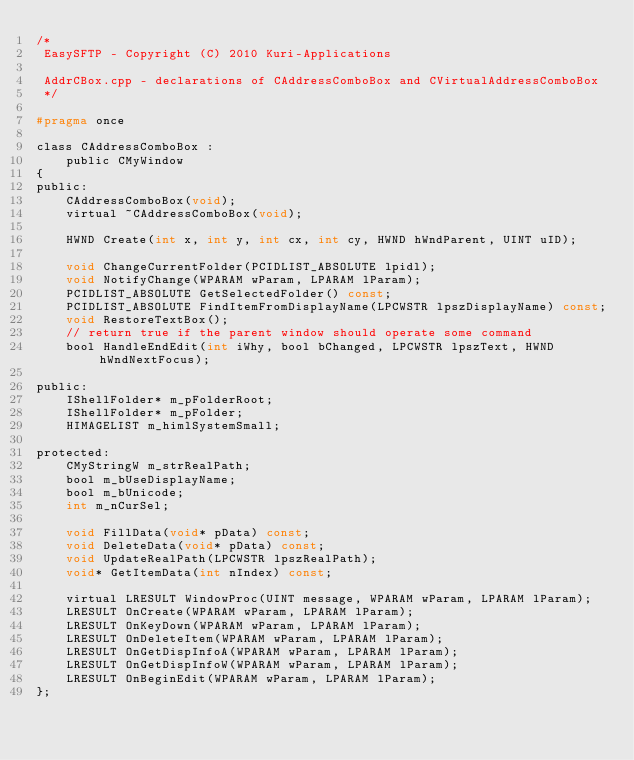<code> <loc_0><loc_0><loc_500><loc_500><_C_>/*
 EasySFTP - Copyright (C) 2010 Kuri-Applications

 AddrCBox.cpp - declarations of CAddressComboBox and CVirtualAddressComboBox
 */

#pragma once

class CAddressComboBox :
	public CMyWindow
{
public:
	CAddressComboBox(void);
	virtual ~CAddressComboBox(void);

	HWND Create(int x, int y, int cx, int cy, HWND hWndParent, UINT uID);

	void ChangeCurrentFolder(PCIDLIST_ABSOLUTE lpidl);
	void NotifyChange(WPARAM wParam, LPARAM lParam);
	PCIDLIST_ABSOLUTE GetSelectedFolder() const;
	PCIDLIST_ABSOLUTE FindItemFromDisplayName(LPCWSTR lpszDisplayName) const;
	void RestoreTextBox();
	// return true if the parent window should operate some command
	bool HandleEndEdit(int iWhy, bool bChanged, LPCWSTR lpszText, HWND hWndNextFocus);

public:
	IShellFolder* m_pFolderRoot;
	IShellFolder* m_pFolder;
	HIMAGELIST m_himlSystemSmall;

protected:
	CMyStringW m_strRealPath;
	bool m_bUseDisplayName;
	bool m_bUnicode;
	int m_nCurSel;

	void FillData(void* pData) const;
	void DeleteData(void* pData) const;
	void UpdateRealPath(LPCWSTR lpszRealPath);
	void* GetItemData(int nIndex) const;

	virtual LRESULT WindowProc(UINT message, WPARAM wParam, LPARAM lParam);
	LRESULT OnCreate(WPARAM wParam, LPARAM lParam);
	LRESULT OnKeyDown(WPARAM wParam, LPARAM lParam);
	LRESULT OnDeleteItem(WPARAM wParam, LPARAM lParam);
	LRESULT OnGetDispInfoA(WPARAM wParam, LPARAM lParam);
	LRESULT OnGetDispInfoW(WPARAM wParam, LPARAM lParam);
	LRESULT OnBeginEdit(WPARAM wParam, LPARAM lParam);
};
</code> 